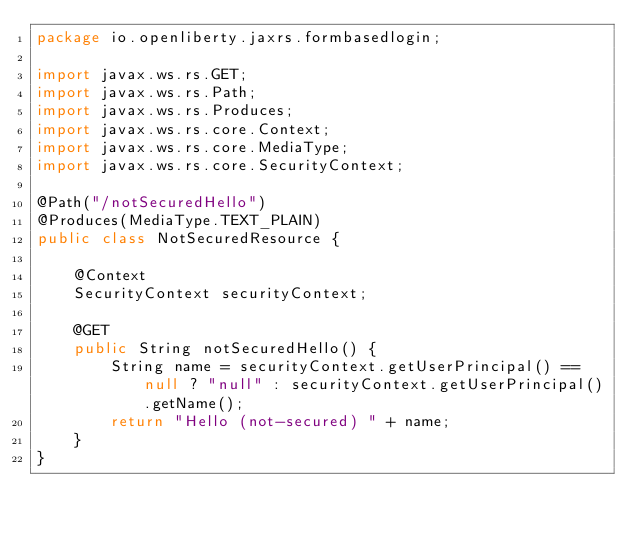Convert code to text. <code><loc_0><loc_0><loc_500><loc_500><_Java_>package io.openliberty.jaxrs.formbasedlogin;

import javax.ws.rs.GET;
import javax.ws.rs.Path;
import javax.ws.rs.Produces;
import javax.ws.rs.core.Context;
import javax.ws.rs.core.MediaType;
import javax.ws.rs.core.SecurityContext;

@Path("/notSecuredHello")
@Produces(MediaType.TEXT_PLAIN)
public class NotSecuredResource {

    @Context
    SecurityContext securityContext;

    @GET
    public String notSecuredHello() {
        String name = securityContext.getUserPrincipal() == null ? "null" : securityContext.getUserPrincipal().getName();
        return "Hello (not-secured) " + name;
    }
}
</code> 